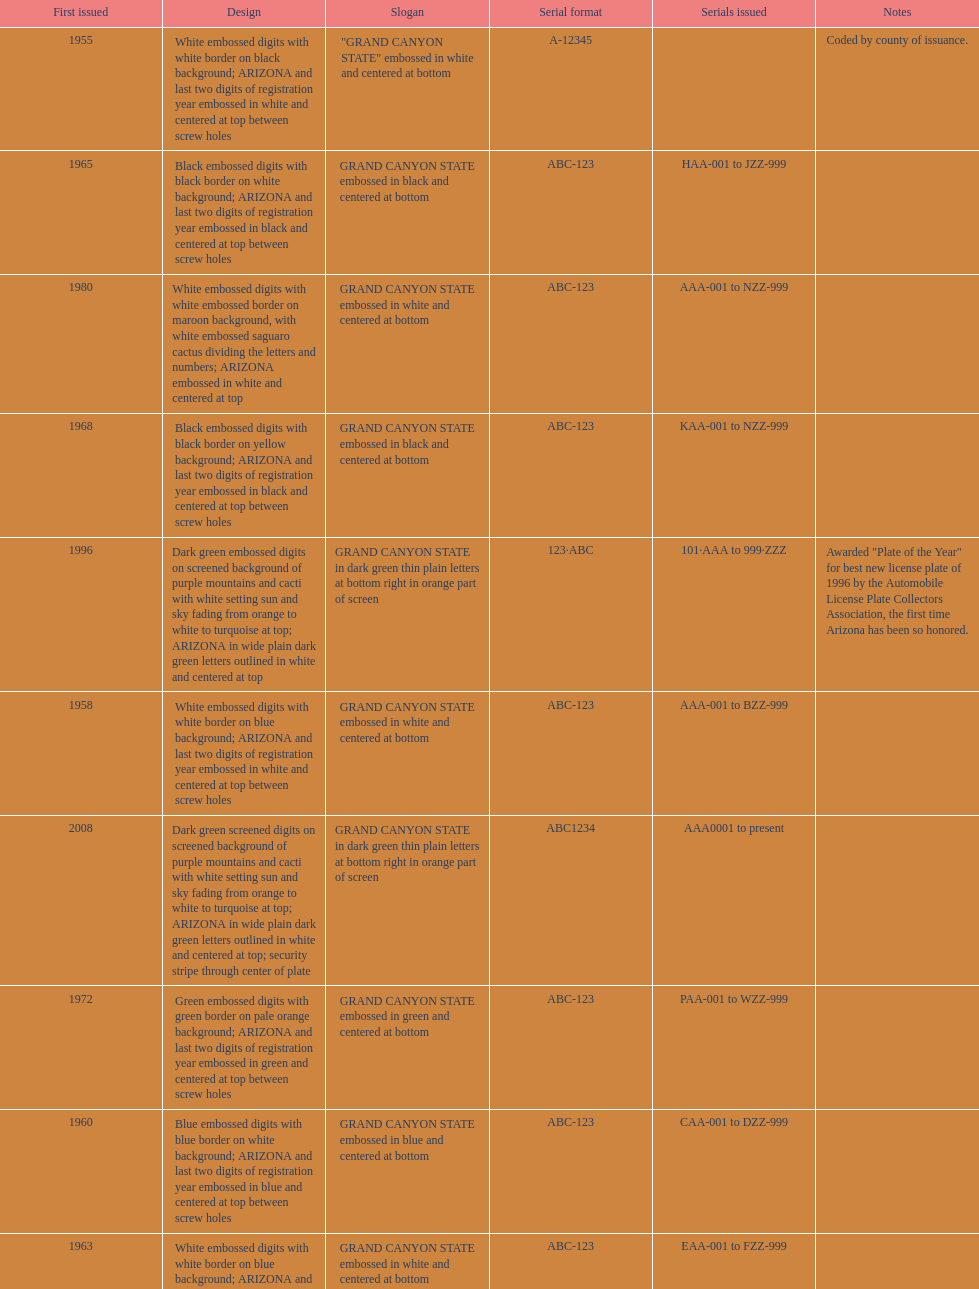Which year featured the license plate with the least characters? 1955. 